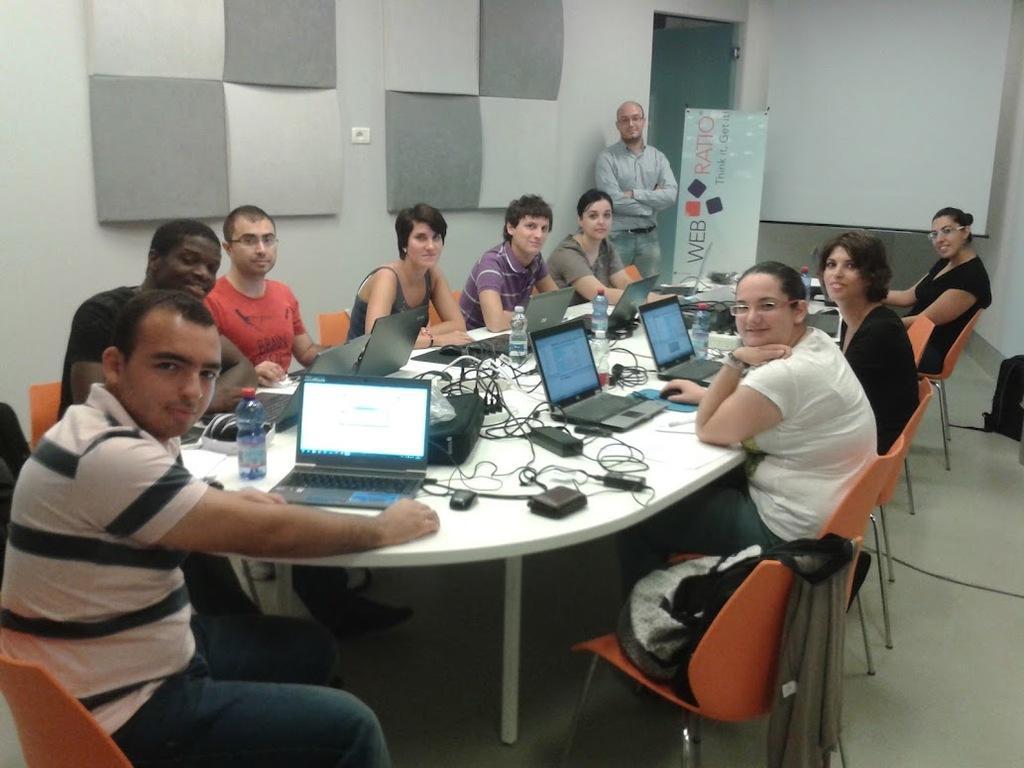How would you summarize this image in a sentence or two? In this image we can see a few people sitting on the chairs and also we can see a person standing and wearing spectacles, in front of them, we can see a table, on the table, we can see laptops, cables, bottles and some other objects, also we can see a bag, projector, door, poster with some text and the wall. 